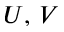<formula> <loc_0><loc_0><loc_500><loc_500>U , \, V</formula> 